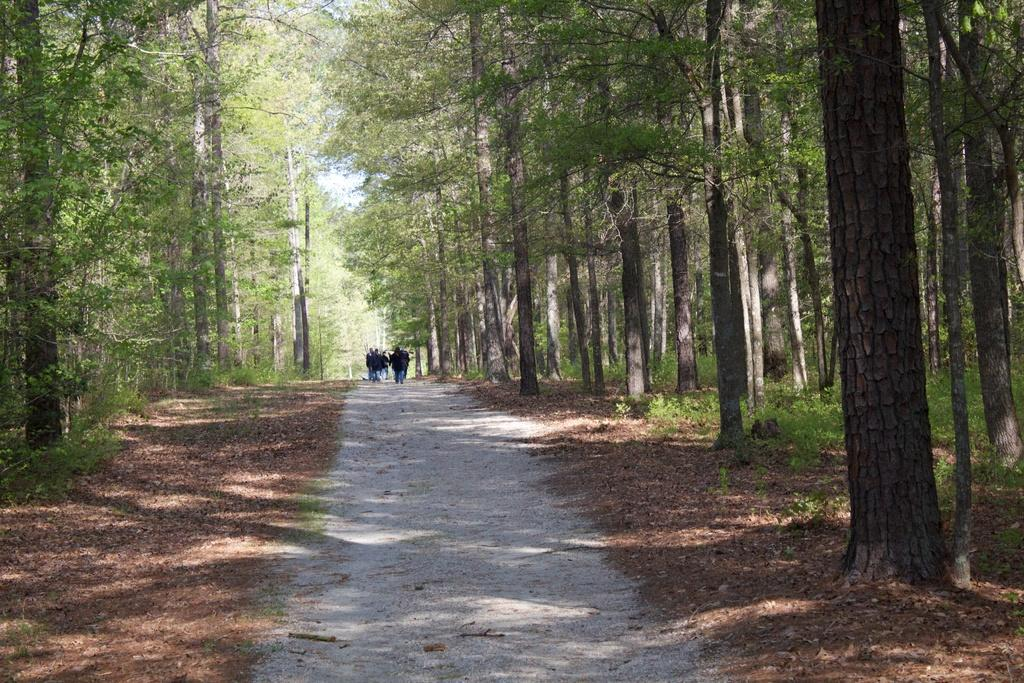What are the people in the image doing? The people in the image are walking on the road. What can be seen in the background of the image? The road is in the middle of trees. What type of control panel can be seen in the image? There is no control panel present in the image; it features people walking on a road surrounded by trees. 